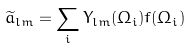Convert formula to latex. <formula><loc_0><loc_0><loc_500><loc_500>\widetilde { a } _ { l m } = \sum _ { i } Y _ { l m } ( \Omega _ { i } ) f ( \Omega _ { i } )</formula> 